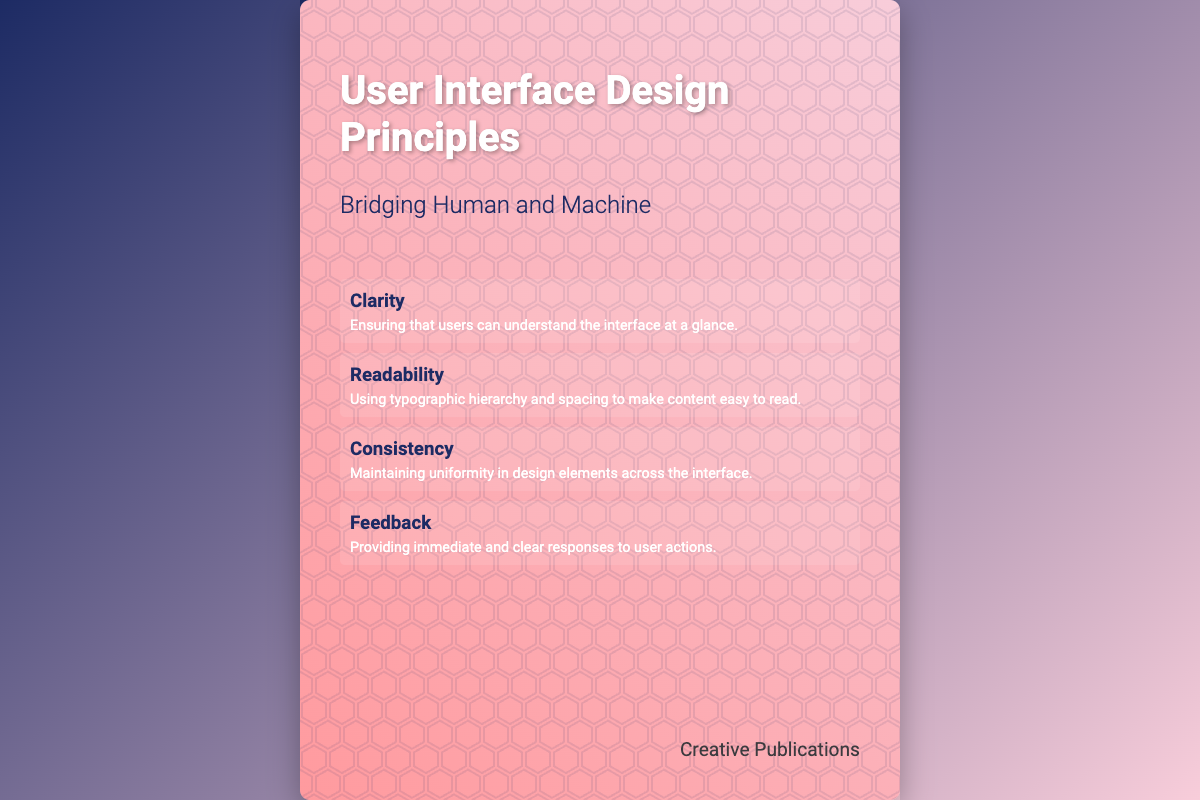what is the title of the book? The title of the book is prominently displayed at the top of the cover.
Answer: User Interface Design Principles who is the author of the book? The author is mentioned at the bottom of the content section of the cover.
Answer: Creative Publications how many principles are listed on the cover? The number of principles can be counted from the principles section on the cover.
Answer: Four what principle focuses on understanding the interface at a glance? The principle's focus is stated clearly in the content section under its title.
Answer: Clarity which principle emphasizes typography and spacing? The principle related to typography and spacing is defined in the principles section.
Answer: Readability what color gradient is used for the background of the book cover? The gradient can be identified by observing the background styles defined for the cover.
Answer: #1D2B64 to #F8CDDA is there any geometric pattern on the cover? The cover features a grid that contains a geometric design as a background layer.
Answer: Yes what is the effect used on the book title? The effect used is a visual enhancement described in the styling details.
Answer: Text-shadow 